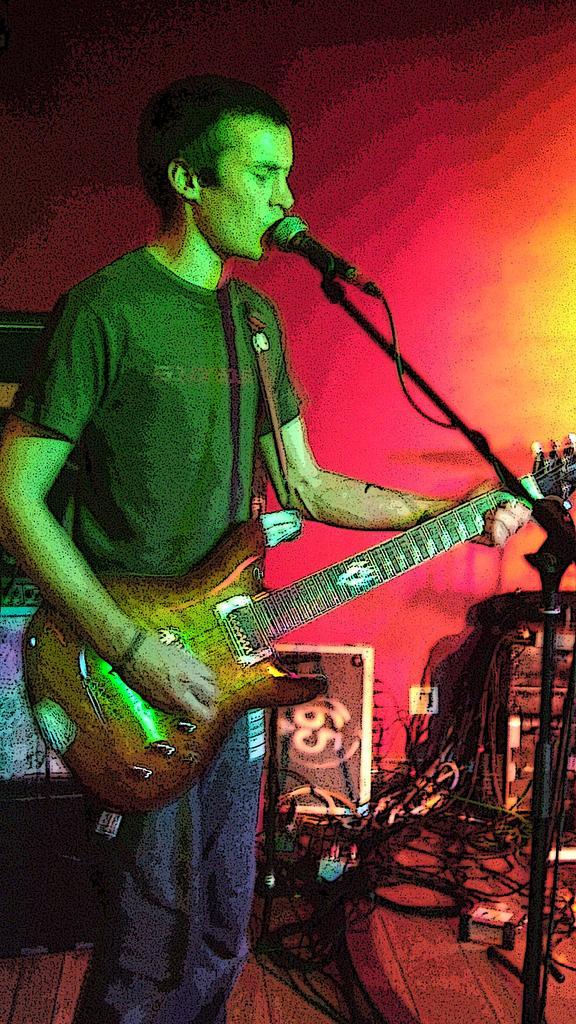Could you give a brief overview of what you see in this image? In this picture there is a boy who is standing at the left side of the image, by holding the guitar in his hands and there is mic in front of him, there are some wires and speakers at the right side of the image. 